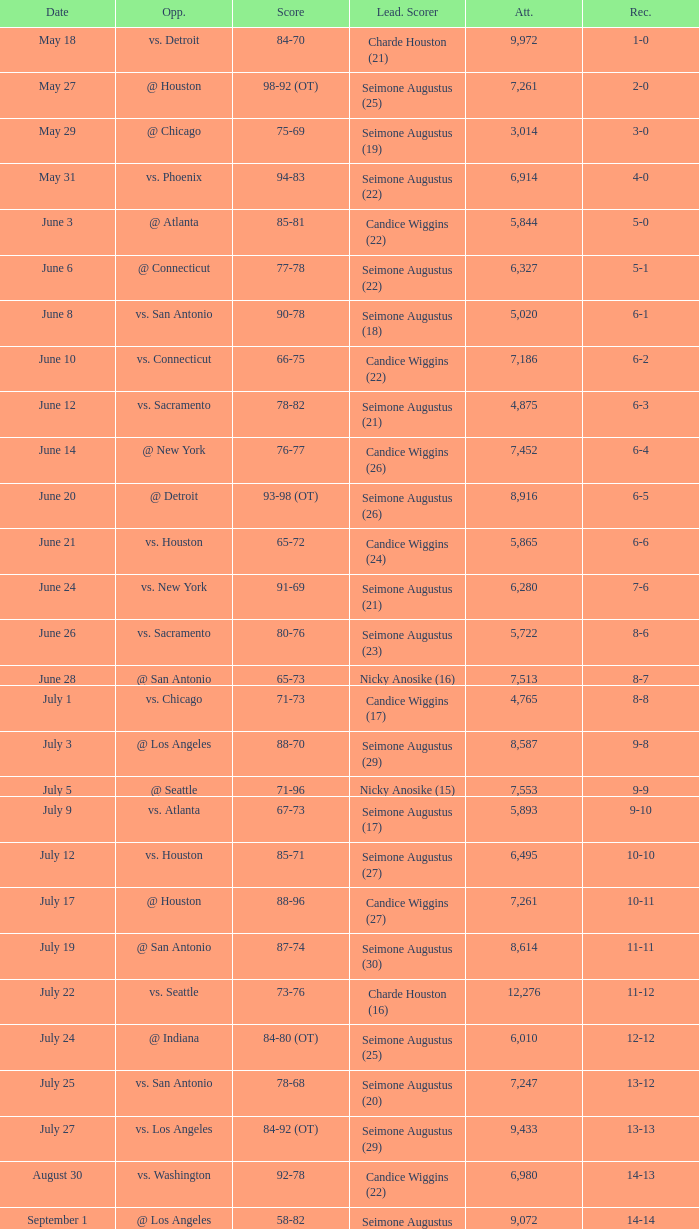Which Score has an Opponent of @ houston, and a Record of 2-0? 98-92 (OT). 